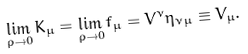Convert formula to latex. <formula><loc_0><loc_0><loc_500><loc_500>\lim _ { \rho \to 0 } { K _ { \mu } } = \lim _ { \rho \to 0 } { f _ { \mu } } = V ^ { \nu } \eta _ { \nu \mu } \equiv { V _ { \mu } } .</formula> 